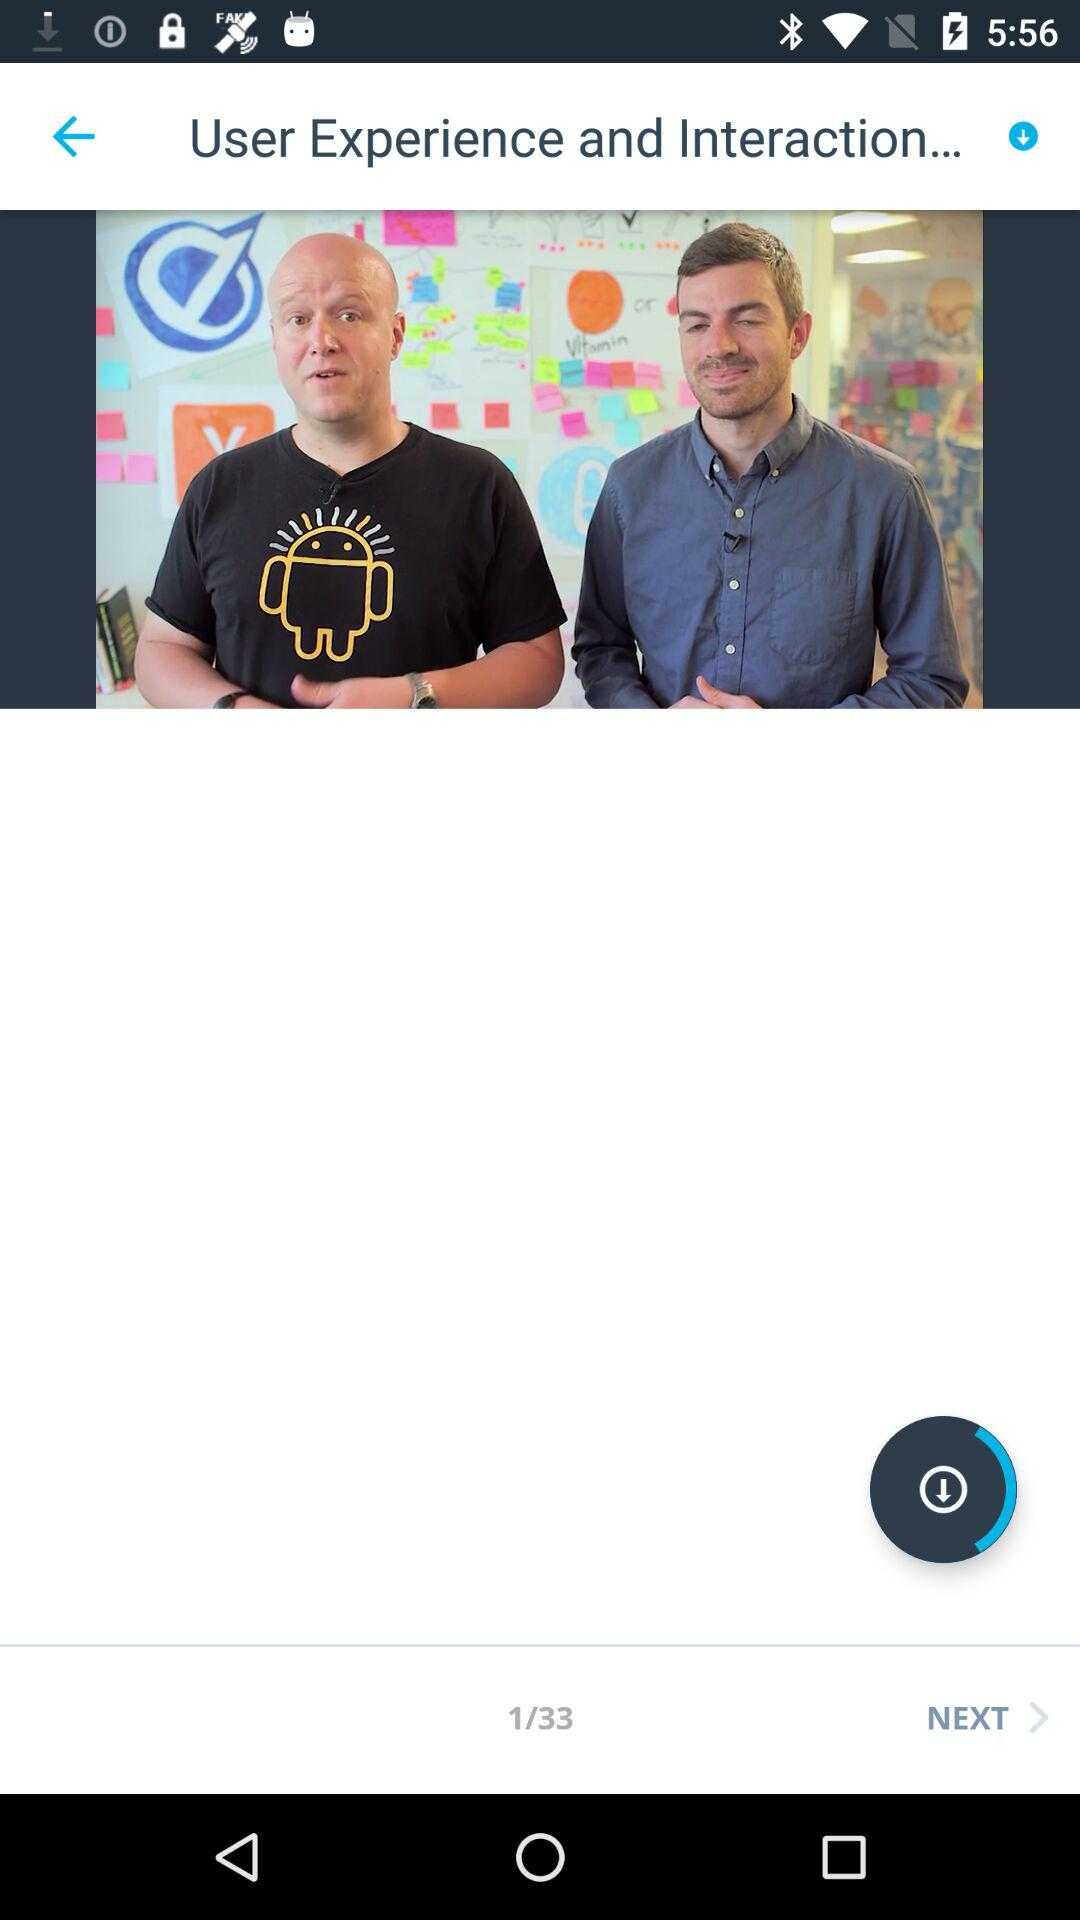Which slide are we on? You are on the first slide. 